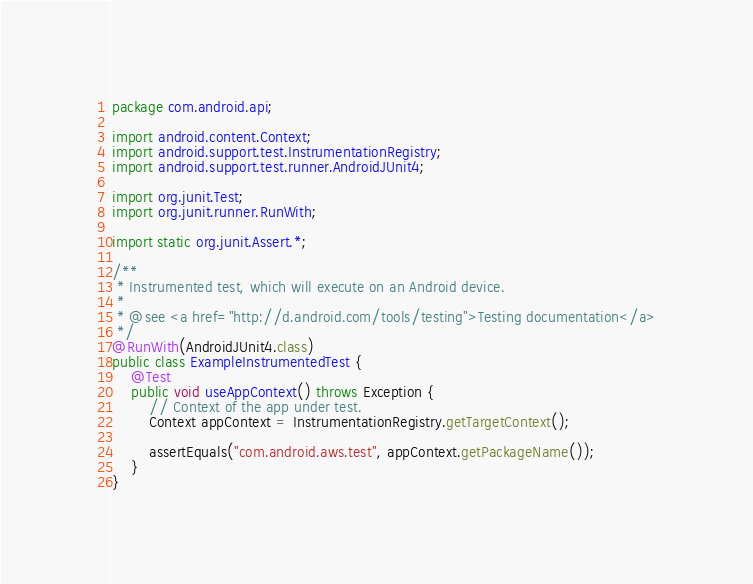<code> <loc_0><loc_0><loc_500><loc_500><_Java_>package com.android.api;

import android.content.Context;
import android.support.test.InstrumentationRegistry;
import android.support.test.runner.AndroidJUnit4;

import org.junit.Test;
import org.junit.runner.RunWith;

import static org.junit.Assert.*;

/**
 * Instrumented test, which will execute on an Android device.
 *
 * @see <a href="http://d.android.com/tools/testing">Testing documentation</a>
 */
@RunWith(AndroidJUnit4.class)
public class ExampleInstrumentedTest {
    @Test
    public void useAppContext() throws Exception {
        // Context of the app under test.
        Context appContext = InstrumentationRegistry.getTargetContext();

        assertEquals("com.android.aws.test", appContext.getPackageName());
    }
}
</code> 